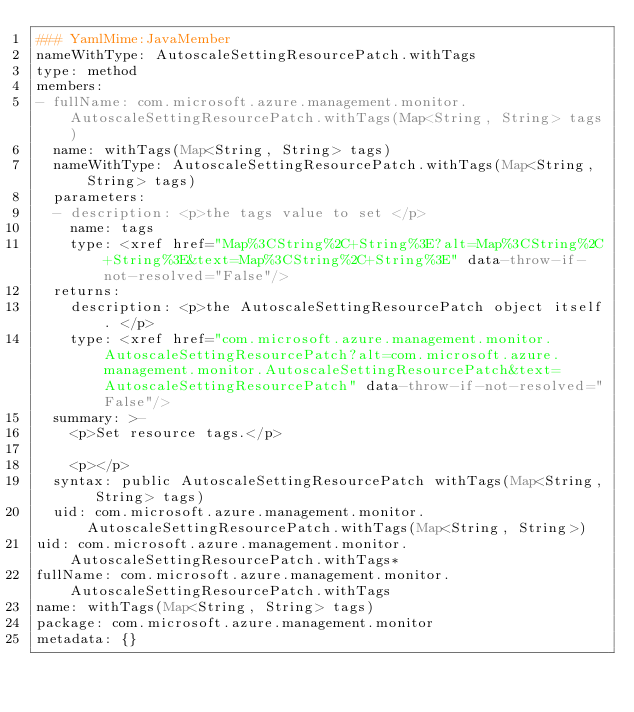Convert code to text. <code><loc_0><loc_0><loc_500><loc_500><_YAML_>### YamlMime:JavaMember
nameWithType: AutoscaleSettingResourcePatch.withTags
type: method
members:
- fullName: com.microsoft.azure.management.monitor.AutoscaleSettingResourcePatch.withTags(Map<String, String> tags)
  name: withTags(Map<String, String> tags)
  nameWithType: AutoscaleSettingResourcePatch.withTags(Map<String, String> tags)
  parameters:
  - description: <p>the tags value to set </p>
    name: tags
    type: <xref href="Map%3CString%2C+String%3E?alt=Map%3CString%2C+String%3E&text=Map%3CString%2C+String%3E" data-throw-if-not-resolved="False"/>
  returns:
    description: <p>the AutoscaleSettingResourcePatch object itself. </p>
    type: <xref href="com.microsoft.azure.management.monitor.AutoscaleSettingResourcePatch?alt=com.microsoft.azure.management.monitor.AutoscaleSettingResourcePatch&text=AutoscaleSettingResourcePatch" data-throw-if-not-resolved="False"/>
  summary: >-
    <p>Set resource tags.</p>

    <p></p>
  syntax: public AutoscaleSettingResourcePatch withTags(Map<String, String> tags)
  uid: com.microsoft.azure.management.monitor.AutoscaleSettingResourcePatch.withTags(Map<String, String>)
uid: com.microsoft.azure.management.monitor.AutoscaleSettingResourcePatch.withTags*
fullName: com.microsoft.azure.management.monitor.AutoscaleSettingResourcePatch.withTags
name: withTags(Map<String, String> tags)
package: com.microsoft.azure.management.monitor
metadata: {}
</code> 